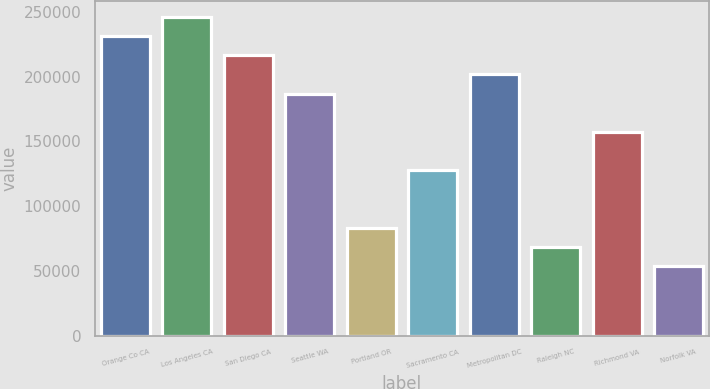Convert chart to OTSL. <chart><loc_0><loc_0><loc_500><loc_500><bar_chart><fcel>Orange Co CA<fcel>Los Angeles CA<fcel>San Diego CA<fcel>Seattle WA<fcel>Portland OR<fcel>Sacramento CA<fcel>Metropolitan DC<fcel>Raleigh NC<fcel>Richmond VA<fcel>Norfolk VA<nl><fcel>231344<fcel>246155<fcel>216532<fcel>186910<fcel>83230.6<fcel>127664<fcel>201721<fcel>68419.3<fcel>157287<fcel>53608<nl></chart> 